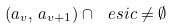<formula> <loc_0><loc_0><loc_500><loc_500>( a _ { v } , \, a _ { v + 1 } ) \cap \ e s i { c } \neq \emptyset</formula> 